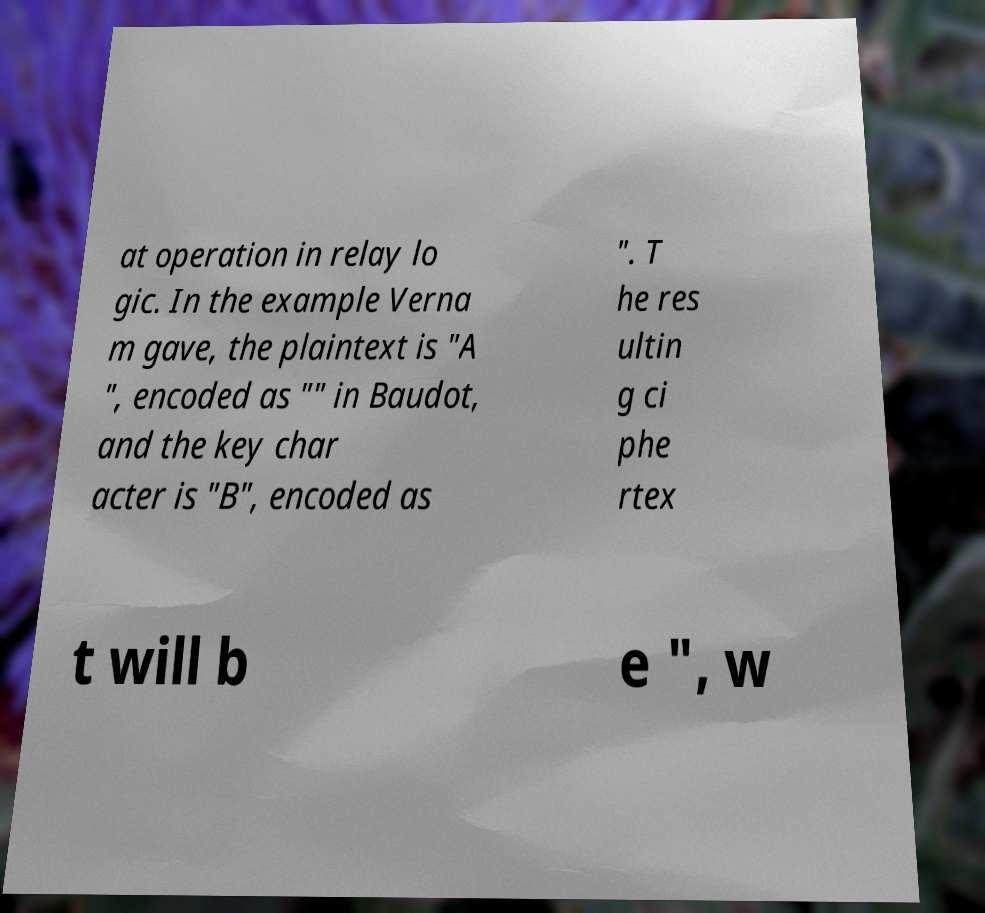There's text embedded in this image that I need extracted. Can you transcribe it verbatim? at operation in relay lo gic. In the example Verna m gave, the plaintext is "A ", encoded as "" in Baudot, and the key char acter is "B", encoded as ". T he res ultin g ci phe rtex t will b e ", w 